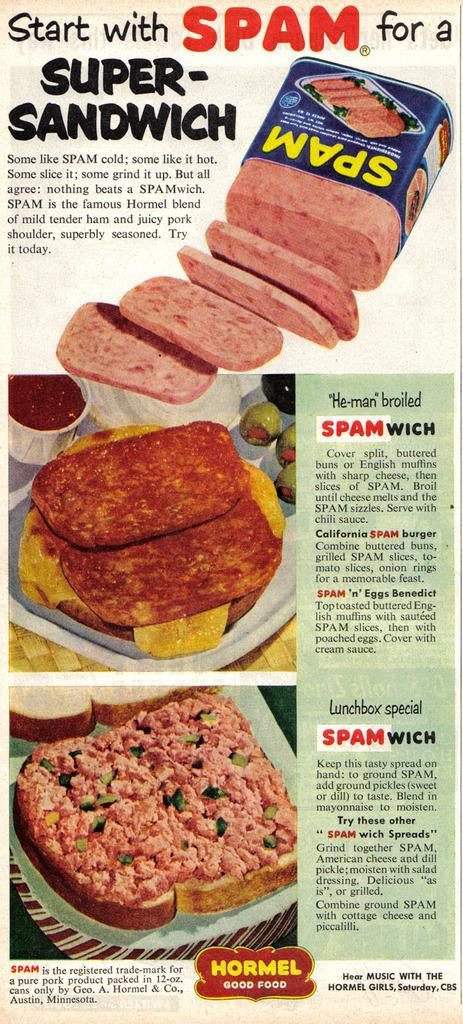What is the main subject in the center of the image? There is a poster in the center of the image. What types of items are depicted on the poster? The poster contains plates, a bowl, food items, and a few other objects. Is there any text present on the poster? Yes, the poster contains text. What type of polish is being applied to the plates in the image? There is no polish being applied to the plates in the image; the poster simply contains images of plates, a bowl, food items, and other objects. Where is the meeting taking place that is depicted in the image? There is no meeting depicted in the image; it only features a poster with various items and text. 